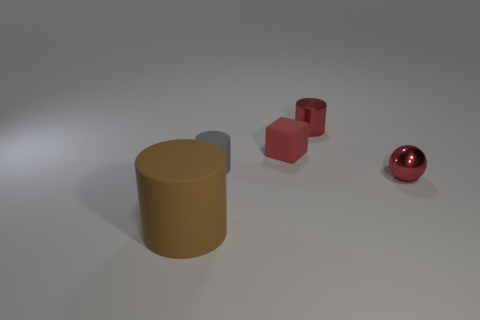Subtract all purple cubes. Subtract all cyan cylinders. How many cubes are left? 1 Add 3 tiny metallic balls. How many objects exist? 8 Subtract all blocks. How many objects are left? 4 Subtract all big cyan matte blocks. Subtract all small things. How many objects are left? 1 Add 5 small metallic things. How many small metallic things are left? 7 Add 2 big cyan metal cylinders. How many big cyan metal cylinders exist? 2 Subtract 1 red blocks. How many objects are left? 4 